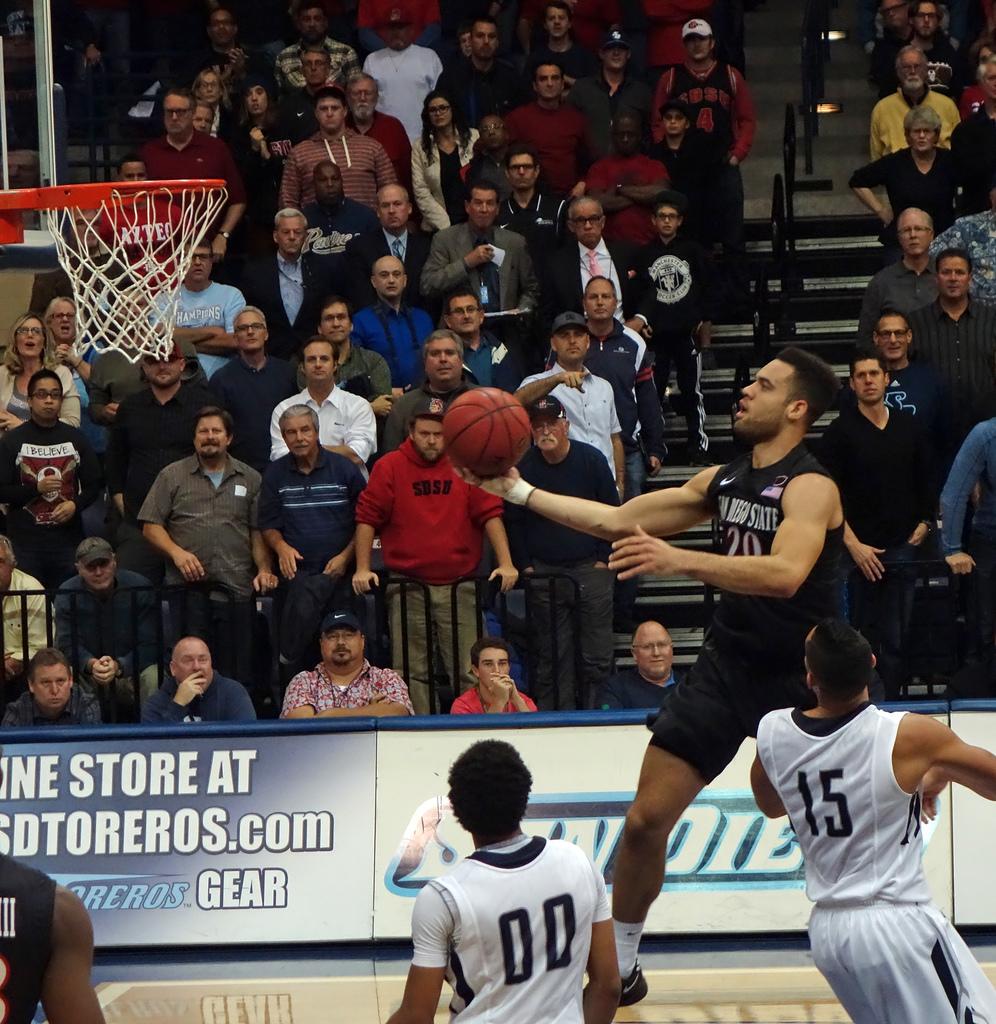What is the number of the player standing on the court watching the other player shoot?
Make the answer very short. 00. 